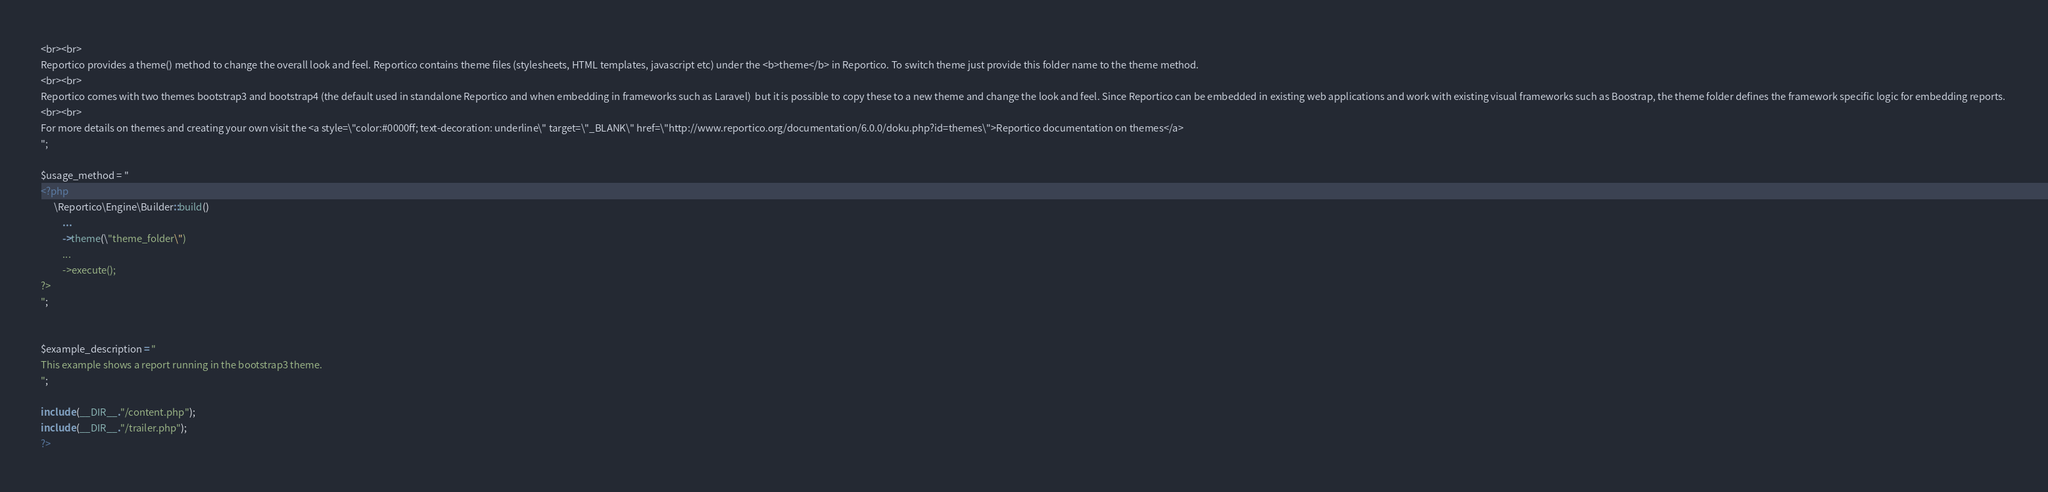<code> <loc_0><loc_0><loc_500><loc_500><_PHP_><br><br>
Reportico provides a theme() method to change the overall look and feel. Reportico contains theme files (stylesheets, HTML templates, javascript etc) under the <b>theme</b> in Reportico. To switch theme just provide this folder name to the theme method.
<br><br>
Reportico comes with two themes bootstrap3 and bootstrap4 (the default used in standalone Reportico and when embedding in frameworks such as Laravel)  but it is possible to copy these to a new theme and change the look and feel. Since Reportico can be embedded in existing web applications and work with existing visual frameworks such as Boostrap, the theme folder defines the framework specific logic for embedding reports. 
<br><br>
For more details on themes and creating your own visit the <a style=\"color:#0000ff; text-decoration: underline\" target=\"_BLANK\" href=\"http://www.reportico.org/documentation/6.0.0/doku.php?id=themes\">Reportico documentation on themes</a>
";

$usage_method = "
<?php
      \Reportico\Engine\Builder::build()
          ...
          ->theme(\"theme_folder\")
          ...
          ->execute();
?>
";


$example_description = "
This example shows a report running in the bootstrap3 theme.
";

include (__DIR__."/content.php");
include (__DIR__."/trailer.php");
?>

</code> 